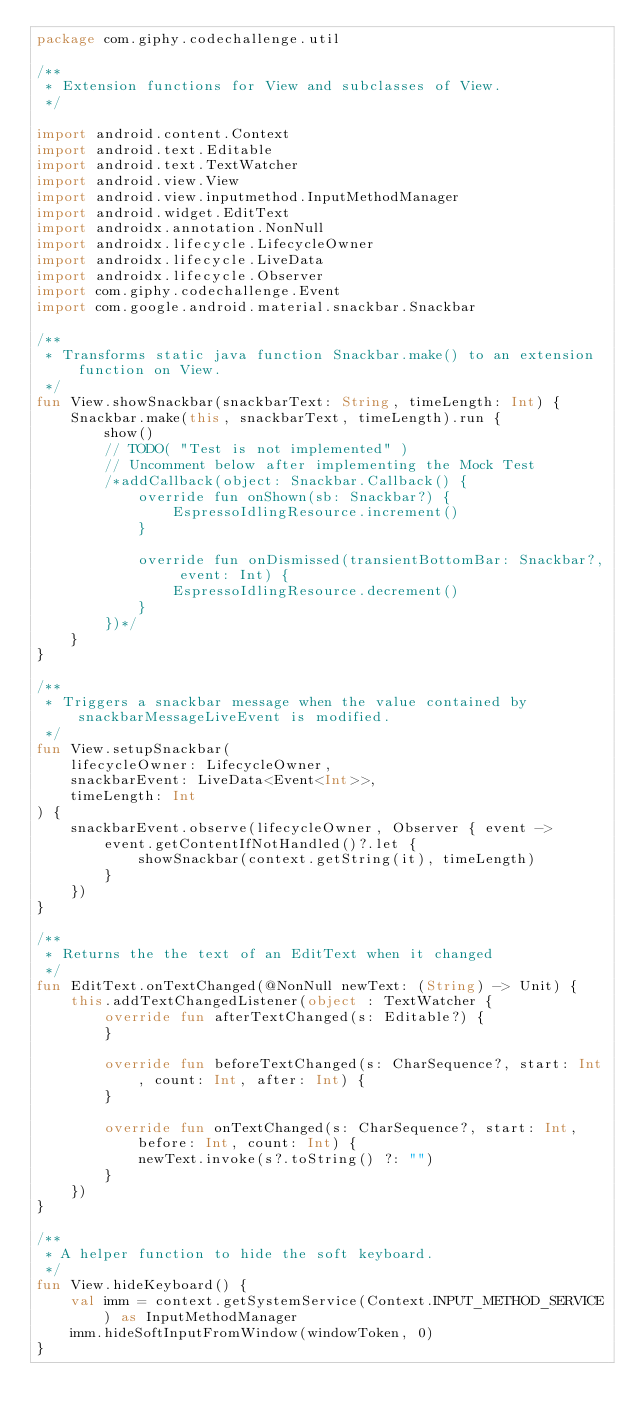Convert code to text. <code><loc_0><loc_0><loc_500><loc_500><_Kotlin_>package com.giphy.codechallenge.util

/**
 * Extension functions for View and subclasses of View.
 */

import android.content.Context
import android.text.Editable
import android.text.TextWatcher
import android.view.View
import android.view.inputmethod.InputMethodManager
import android.widget.EditText
import androidx.annotation.NonNull
import androidx.lifecycle.LifecycleOwner
import androidx.lifecycle.LiveData
import androidx.lifecycle.Observer
import com.giphy.codechallenge.Event
import com.google.android.material.snackbar.Snackbar

/**
 * Transforms static java function Snackbar.make() to an extension function on View.
 */
fun View.showSnackbar(snackbarText: String, timeLength: Int) {
    Snackbar.make(this, snackbarText, timeLength).run {
        show()
        // TODO( "Test is not implemented" )
        // Uncomment below after implementing the Mock Test
        /*addCallback(object: Snackbar.Callback() {
            override fun onShown(sb: Snackbar?) {
                EspressoIdlingResource.increment()
            }

            override fun onDismissed(transientBottomBar: Snackbar?, event: Int) {
                EspressoIdlingResource.decrement()
            }
        })*/
    }
}

/**
 * Triggers a snackbar message when the value contained by snackbarMessageLiveEvent is modified.
 */
fun View.setupSnackbar(
    lifecycleOwner: LifecycleOwner,
    snackbarEvent: LiveData<Event<Int>>,
    timeLength: Int
) {
    snackbarEvent.observe(lifecycleOwner, Observer { event ->
        event.getContentIfNotHandled()?.let {
            showSnackbar(context.getString(it), timeLength)
        }
    })
}

/**
 * Returns the the text of an EditText when it changed
 */
fun EditText.onTextChanged(@NonNull newText: (String) -> Unit) {
    this.addTextChangedListener(object : TextWatcher {
        override fun afterTextChanged(s: Editable?) {
        }

        override fun beforeTextChanged(s: CharSequence?, start: Int, count: Int, after: Int) {
        }

        override fun onTextChanged(s: CharSequence?, start: Int, before: Int, count: Int) {
            newText.invoke(s?.toString() ?: "")
        }
    })
}

/**
 * A helper function to hide the soft keyboard.
 */
fun View.hideKeyboard() {
    val imm = context.getSystemService(Context.INPUT_METHOD_SERVICE) as InputMethodManager
    imm.hideSoftInputFromWindow(windowToken, 0)
}</code> 